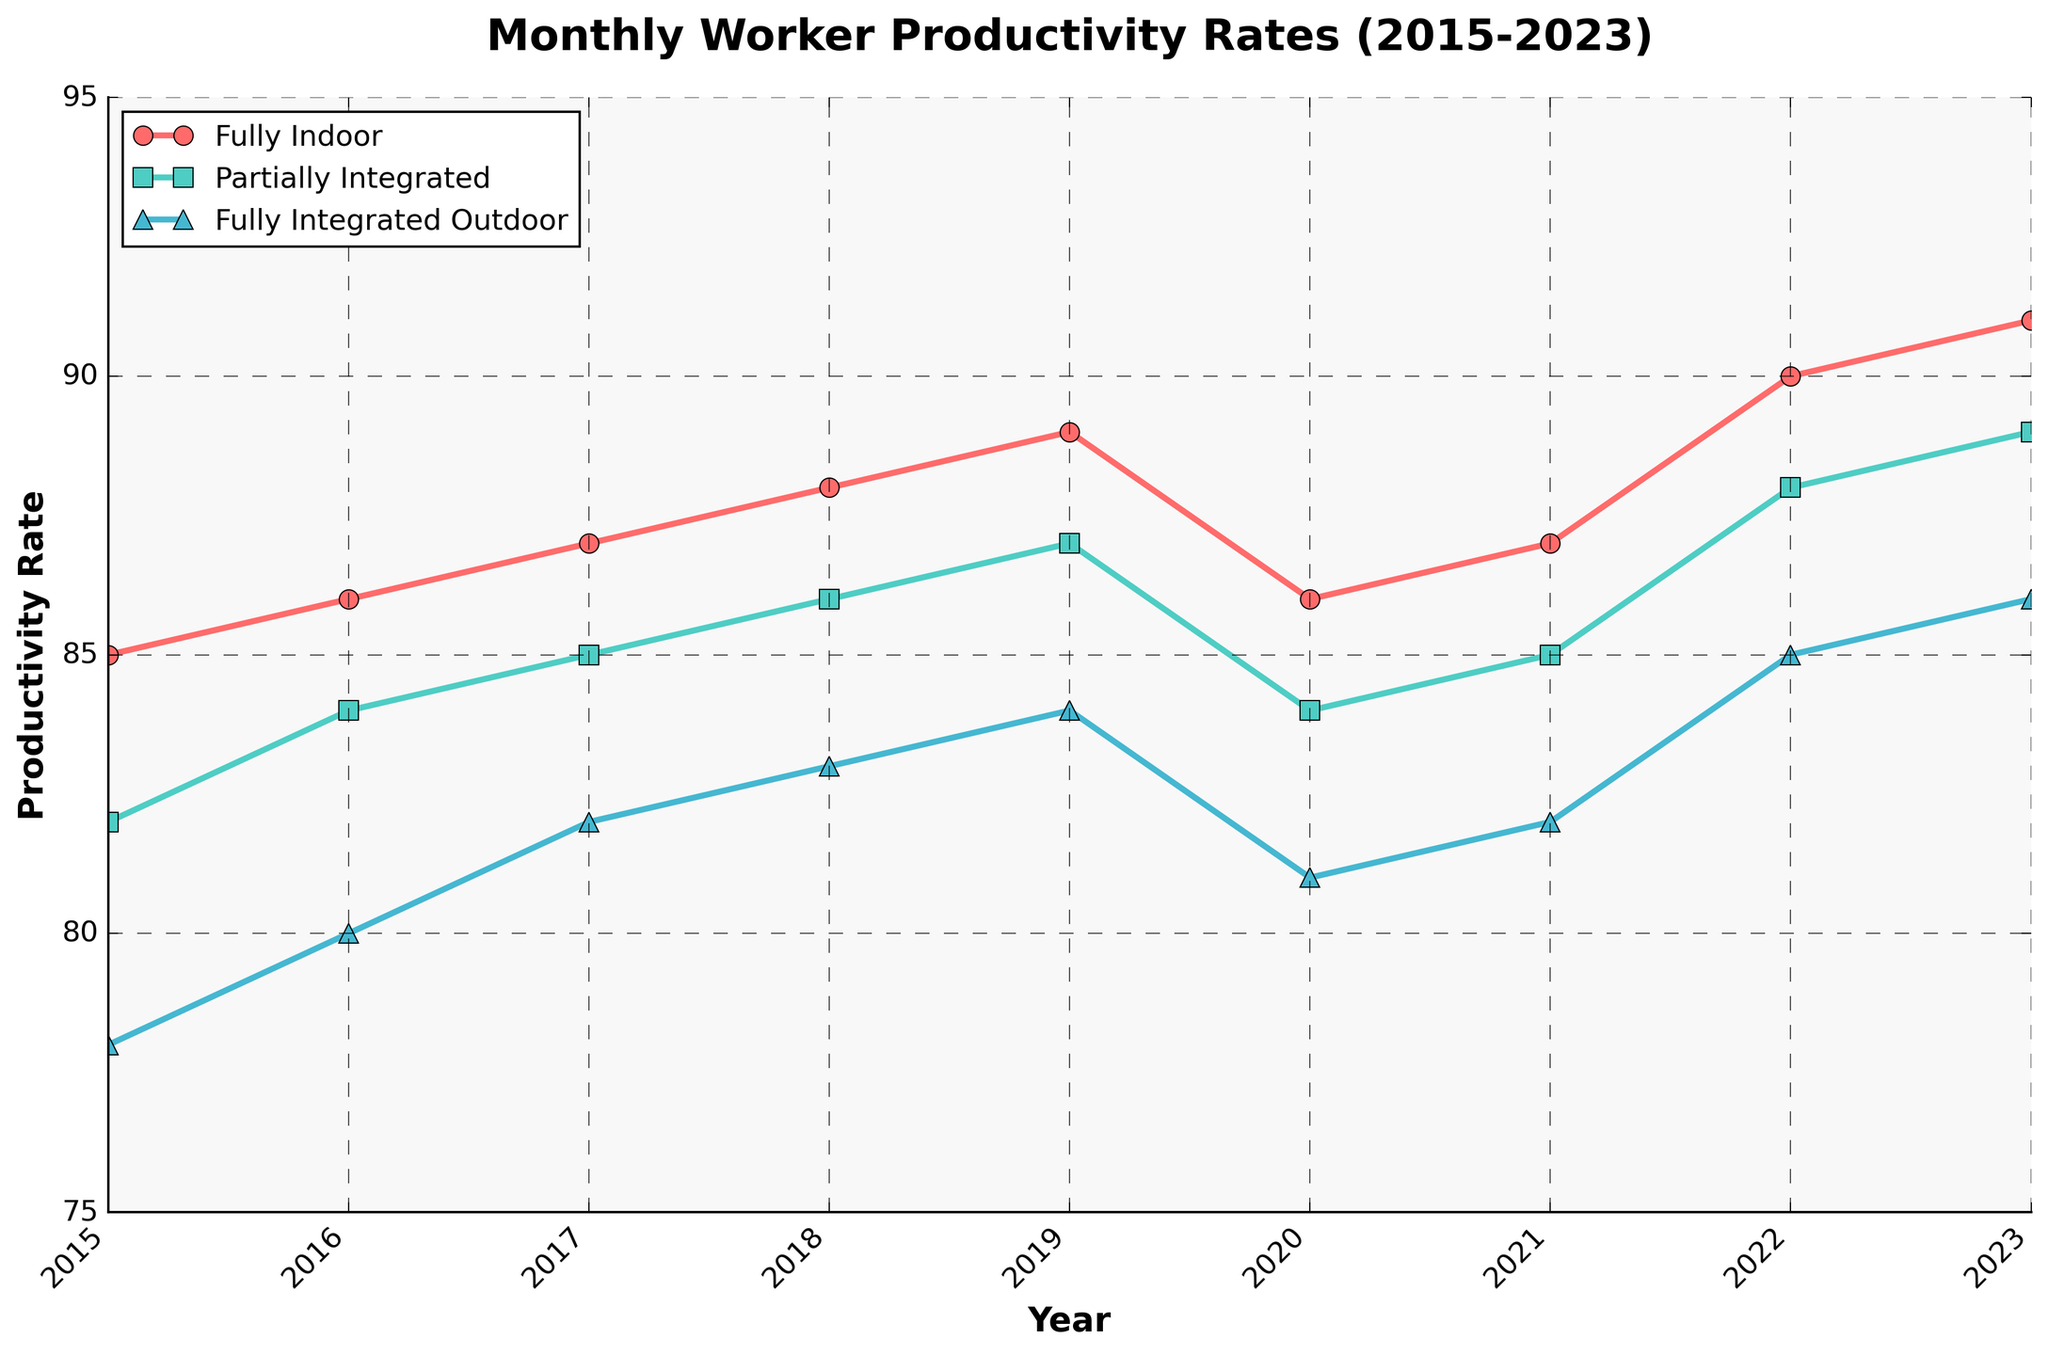What was the productivity rate for Fully Indoor projects in January 2023? Locate the Fully Indoor data line and find the data point corresponding to January 2023 on the x-axis, which is labeled as the year. The productivity rate is at that point.
Answer: 91 How did the productivity rate for Fully Integrated Outdoor projects in January 2017 compare to that in January 2022? Locate the Fully Integrated Outdoor data line and compare the values at the January 2017 and January 2022 data points on the x-axis. January 2017 shows a productivity rate of 82, while January 2022 shows 85.
Answer: 82 vs 85 What is the trend in productivity rates for Partially Integrated projects from 2015 to 2023? Observe the Partially Integrated data line from 2015 to 2023. The line rises over the years, indicating an increasing trend in productivity rates.
Answer: Increasing Which type of project had the highest productivity rate in January 2019? Identify the productivity rates for all three project types in January 2019 by checking the three data lines. Fully Indoor projects had the highest rate at 89.
Answer: Fully Indoor What is the average productivity rate for Fully Integrated Outdoor projects in January for the years 2020 to 2023? Identify the values for Fully Integrated Outdoor projects in January 2020 (81), 2021 (82), 2022 (85), and 2023 (86). Sum these values and divide by the number of years (4): (81 + 82 + 85 + 86)/4 = 83.5.
Answer: 83.5 What is the difference in the productivity rate between Fully Indoor and Partially Integrated projects in January 2022? Locate the productivity rates for Fully Indoor (90) and Partially Integrated (88) projects in January 2022. Subtract the Partially Integrated rate from the Fully Indoor rate (90 - 88).
Answer: 2 Which month generally shows higher productivity rates, January or July? Compare productivity rates in January and July for all years and all project types. July consistently shows higher productivity rates than January for every year and project type.
Answer: July How much did the productivity rate for Partially Integrated projects increase from January 2015 to January 2023? Find the productivity rates for Partially Integrated projects in January 2015 (82) and January 2023 (89). Subtract the 2015 value from the 2023 value (89 - 82).
Answer: 7 Are there any years where Fully Indoor and Fully Integrated Outdoor projects had the same productivity rate? Compare the data lines for Fully Indoor and Fully Integrated Outdoor over the years. There are no years where their productivity rates are identical.
Answer: No By how much did Fully Integrated Outdoor project productivity increase between January 2020 and January 2022? Find the productivity rates in January 2020 (81) and January 2022 (85) for Fully Integrated Outdoor projects. Subtract the 2020 value from the 2022 value (85 - 81).
Answer: 4 